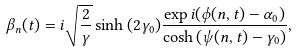Convert formula to latex. <formula><loc_0><loc_0><loc_500><loc_500>\beta _ { n } ( t ) = i \sqrt { \frac { 2 } { \gamma } } \sinh { ( 2 \gamma _ { 0 } ) } \frac { \exp { i ( \phi ( n , t ) - \alpha _ { 0 } ) } } { \cosh { ( \psi ( n , t ) - \gamma _ { 0 } ) } } ,</formula> 